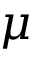<formula> <loc_0><loc_0><loc_500><loc_500>\mu</formula> 